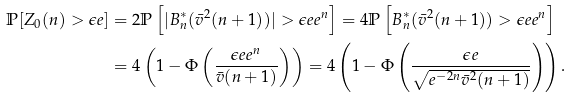<formula> <loc_0><loc_0><loc_500><loc_500>\mathbb { P } [ Z _ { 0 } ( n ) > \epsilon e ] & = 2 \mathbb { P } \left [ | B ^ { \ast } _ { n } ( \bar { v } ^ { 2 } ( n + 1 ) ) | > \epsilon e e ^ { n } \right ] = 4 \mathbb { P } \left [ B ^ { \ast } _ { n } ( \bar { v } ^ { 2 } ( n + 1 ) ) > \epsilon e e ^ { n } \right ] \\ & = 4 \left ( 1 - \Phi \left ( \frac { \epsilon e e ^ { n } } { \bar { v } ( n + 1 ) } \right ) \right ) = 4 \left ( 1 - \Phi \left ( \frac { \epsilon e } { \sqrt { e ^ { - 2 n } \bar { v } ^ { 2 } ( n + 1 ) } } \right ) \right ) .</formula> 